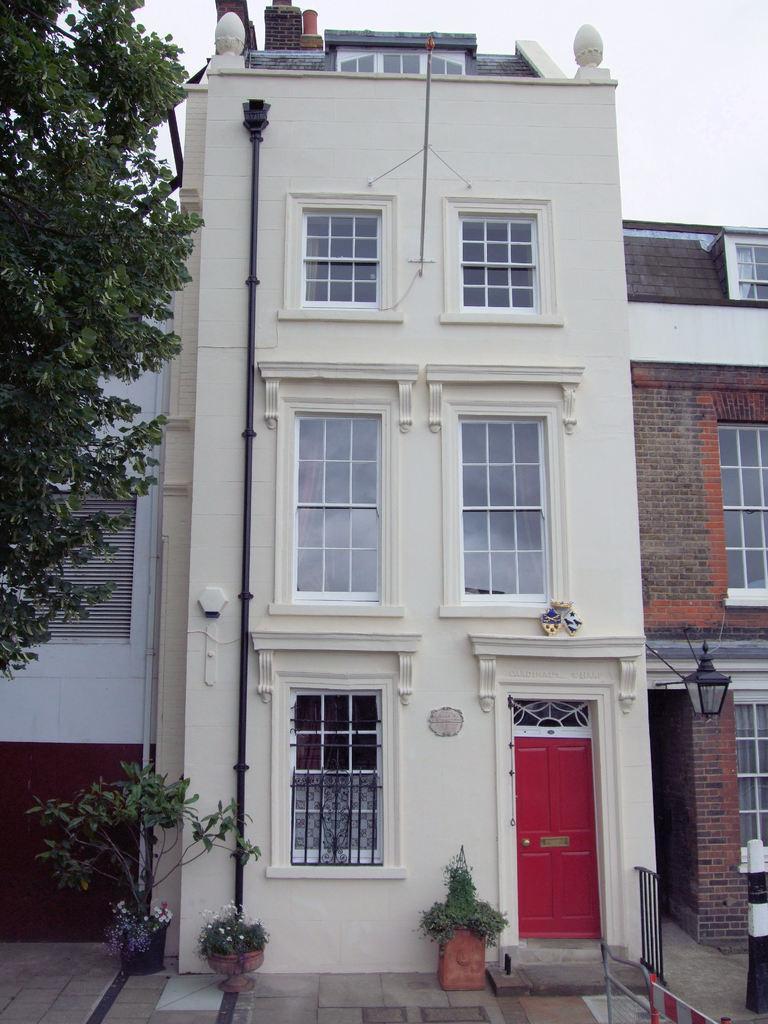How would you summarize this image in a sentence or two? In this picture I can see few buildings, plants and a tree in the front and I can see the sky in the background. On the right side of this picture I can see the railing. 